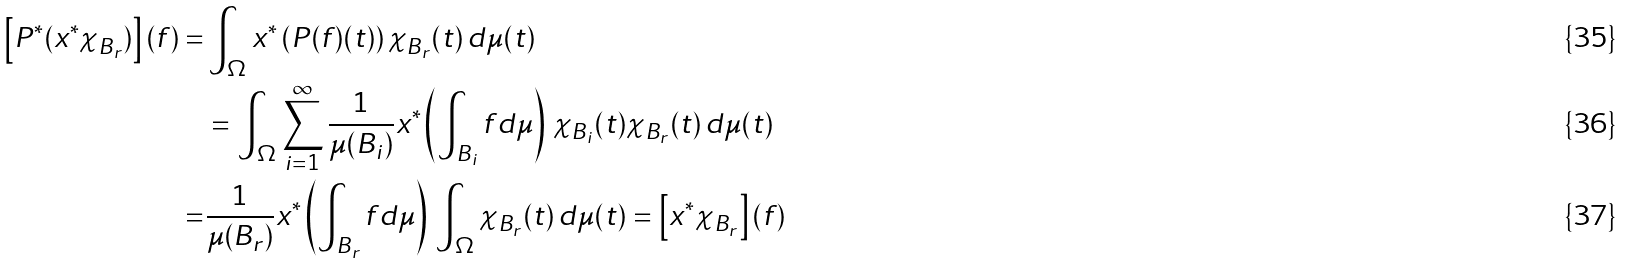Convert formula to latex. <formula><loc_0><loc_0><loc_500><loc_500>\left [ P ^ { * } ( x ^ { * } \chi _ { B _ { r } } ) \right ] ( f ) = & \int _ { \Omega } x ^ { * } \left ( P ( f ) ( t ) \right ) \chi _ { B _ { r } } ( t ) \, d \mu ( t ) \\ & = \int _ { \Omega } \sum _ { i = 1 } ^ { \infty } \frac { 1 } { \mu ( B _ { i } ) } x ^ { * } \left ( \int _ { B _ { i } } f d \mu \right ) \, \chi _ { B _ { i } } ( t ) \chi _ { B _ { r } } ( t ) \, d \mu ( t ) \\ = & \frac { 1 } { \mu ( B _ { r } ) } x ^ { * } \left ( \int _ { B _ { r } } f d \mu \right ) \, \int _ { \Omega } \chi _ { B _ { r } } ( t ) \, d \mu ( t ) = \left [ x ^ { * } \chi _ { B _ { r } } \right ] ( f )</formula> 